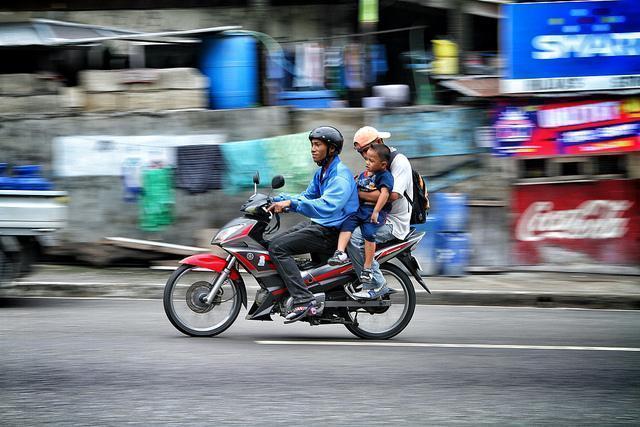What year was Coca-Cola founded?
Answer the question by selecting the correct answer among the 4 following choices and explain your choice with a short sentence. The answer should be formatted with the following format: `Answer: choice
Rationale: rationale.`
Options: 1843, 1892, 1881, 1890. Answer: 1892.
Rationale: The coca cola company, featured here in the advertisement on the right side of the picture was founded 1892. 